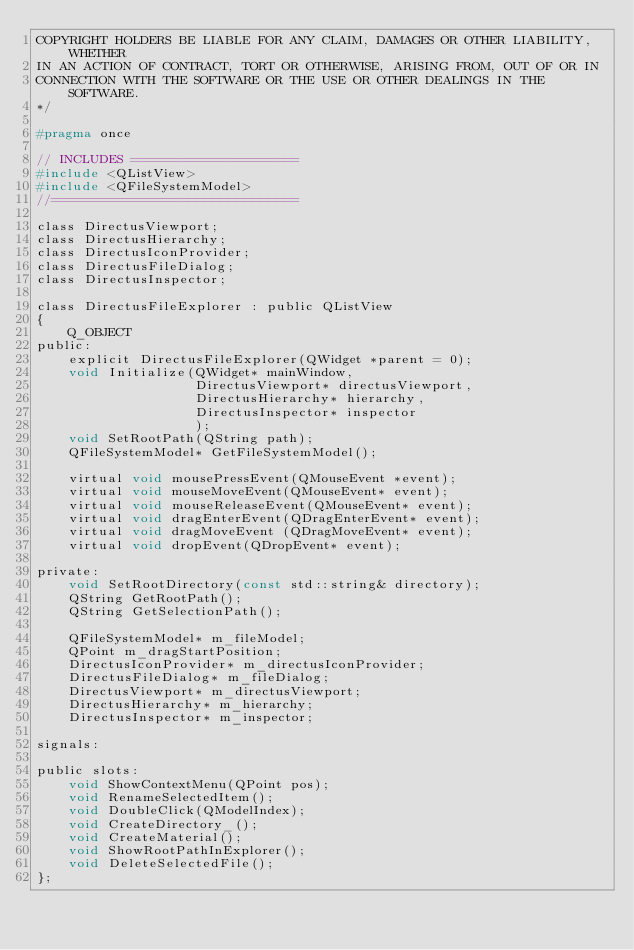Convert code to text. <code><loc_0><loc_0><loc_500><loc_500><_C_>COPYRIGHT HOLDERS BE LIABLE FOR ANY CLAIM, DAMAGES OR OTHER LIABILITY, WHETHER
IN AN ACTION OF CONTRACT, TORT OR OTHERWISE, ARISING FROM, OUT OF OR IN
CONNECTION WITH THE SOFTWARE OR THE USE OR OTHER DEALINGS IN THE SOFTWARE.
*/

#pragma once

// INCLUDES =====================
#include <QListView>
#include <QFileSystemModel>
//===============================

class DirectusViewport;
class DirectusHierarchy;
class DirectusIconProvider;
class DirectusFileDialog;
class DirectusInspector;

class DirectusFileExplorer : public QListView
{
    Q_OBJECT
public:
    explicit DirectusFileExplorer(QWidget *parent = 0);
    void Initialize(QWidget* mainWindow,
                    DirectusViewport* directusViewport,
                    DirectusHierarchy* hierarchy,
                    DirectusInspector* inspector
                    );
    void SetRootPath(QString path);
    QFileSystemModel* GetFileSystemModel();

    virtual void mousePressEvent(QMouseEvent *event);
    virtual void mouseMoveEvent(QMouseEvent* event);
    virtual void mouseReleaseEvent(QMouseEvent* event);
    virtual void dragEnterEvent(QDragEnterEvent* event);
    virtual void dragMoveEvent (QDragMoveEvent* event);
    virtual void dropEvent(QDropEvent* event);

private:
    void SetRootDirectory(const std::string& directory);
    QString GetRootPath();
    QString GetSelectionPath();

    QFileSystemModel* m_fileModel;
    QPoint m_dragStartPosition;
    DirectusIconProvider* m_directusIconProvider;
    DirectusFileDialog* m_fileDialog;
    DirectusViewport* m_directusViewport;
    DirectusHierarchy* m_hierarchy;
    DirectusInspector* m_inspector;

signals:

public slots:
    void ShowContextMenu(QPoint pos);
    void RenameSelectedItem();
    void DoubleClick(QModelIndex);
    void CreateDirectory_();
    void CreateMaterial();
    void ShowRootPathInExplorer();
    void DeleteSelectedFile();
};
</code> 